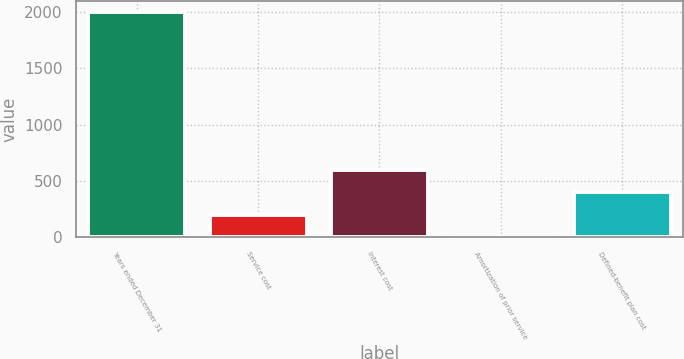Convert chart to OTSL. <chart><loc_0><loc_0><loc_500><loc_500><bar_chart><fcel>Years ended December 31<fcel>Service cost<fcel>Interest cost<fcel>Amortization of prior service<fcel>Defined-benefit plan cost<nl><fcel>2001<fcel>201<fcel>601<fcel>1<fcel>401<nl></chart> 